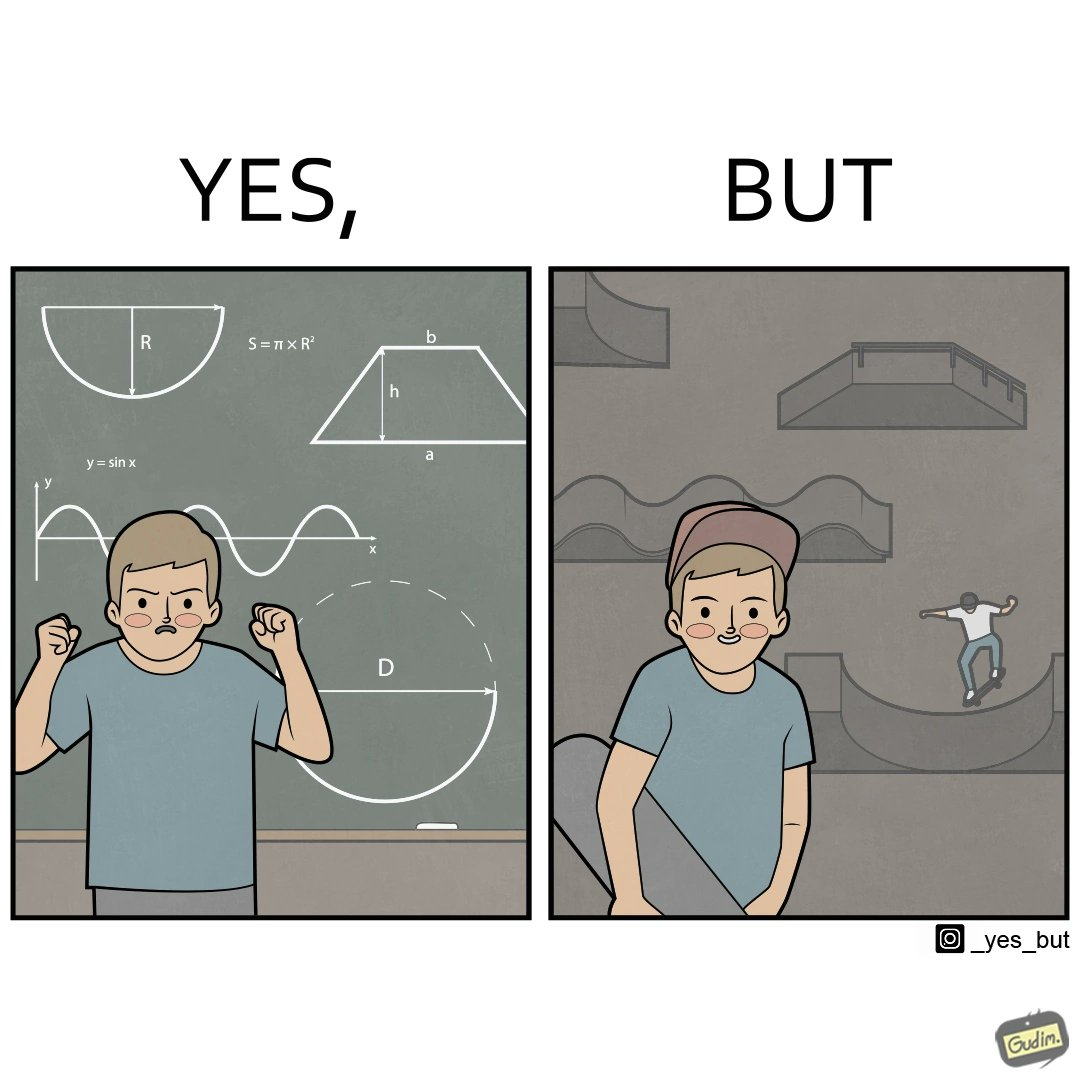What is shown in this image? The image is ironical beaucse while the boy does not enjoy studying mathematics and different geometric shapes like semi circle and trapezoid and graphs of trigonometric equations like that of a sine wave, he enjoys skateboarding on surfaces and bowls that are built based on the said geometric shapes and graphs of trigonometric equations. 